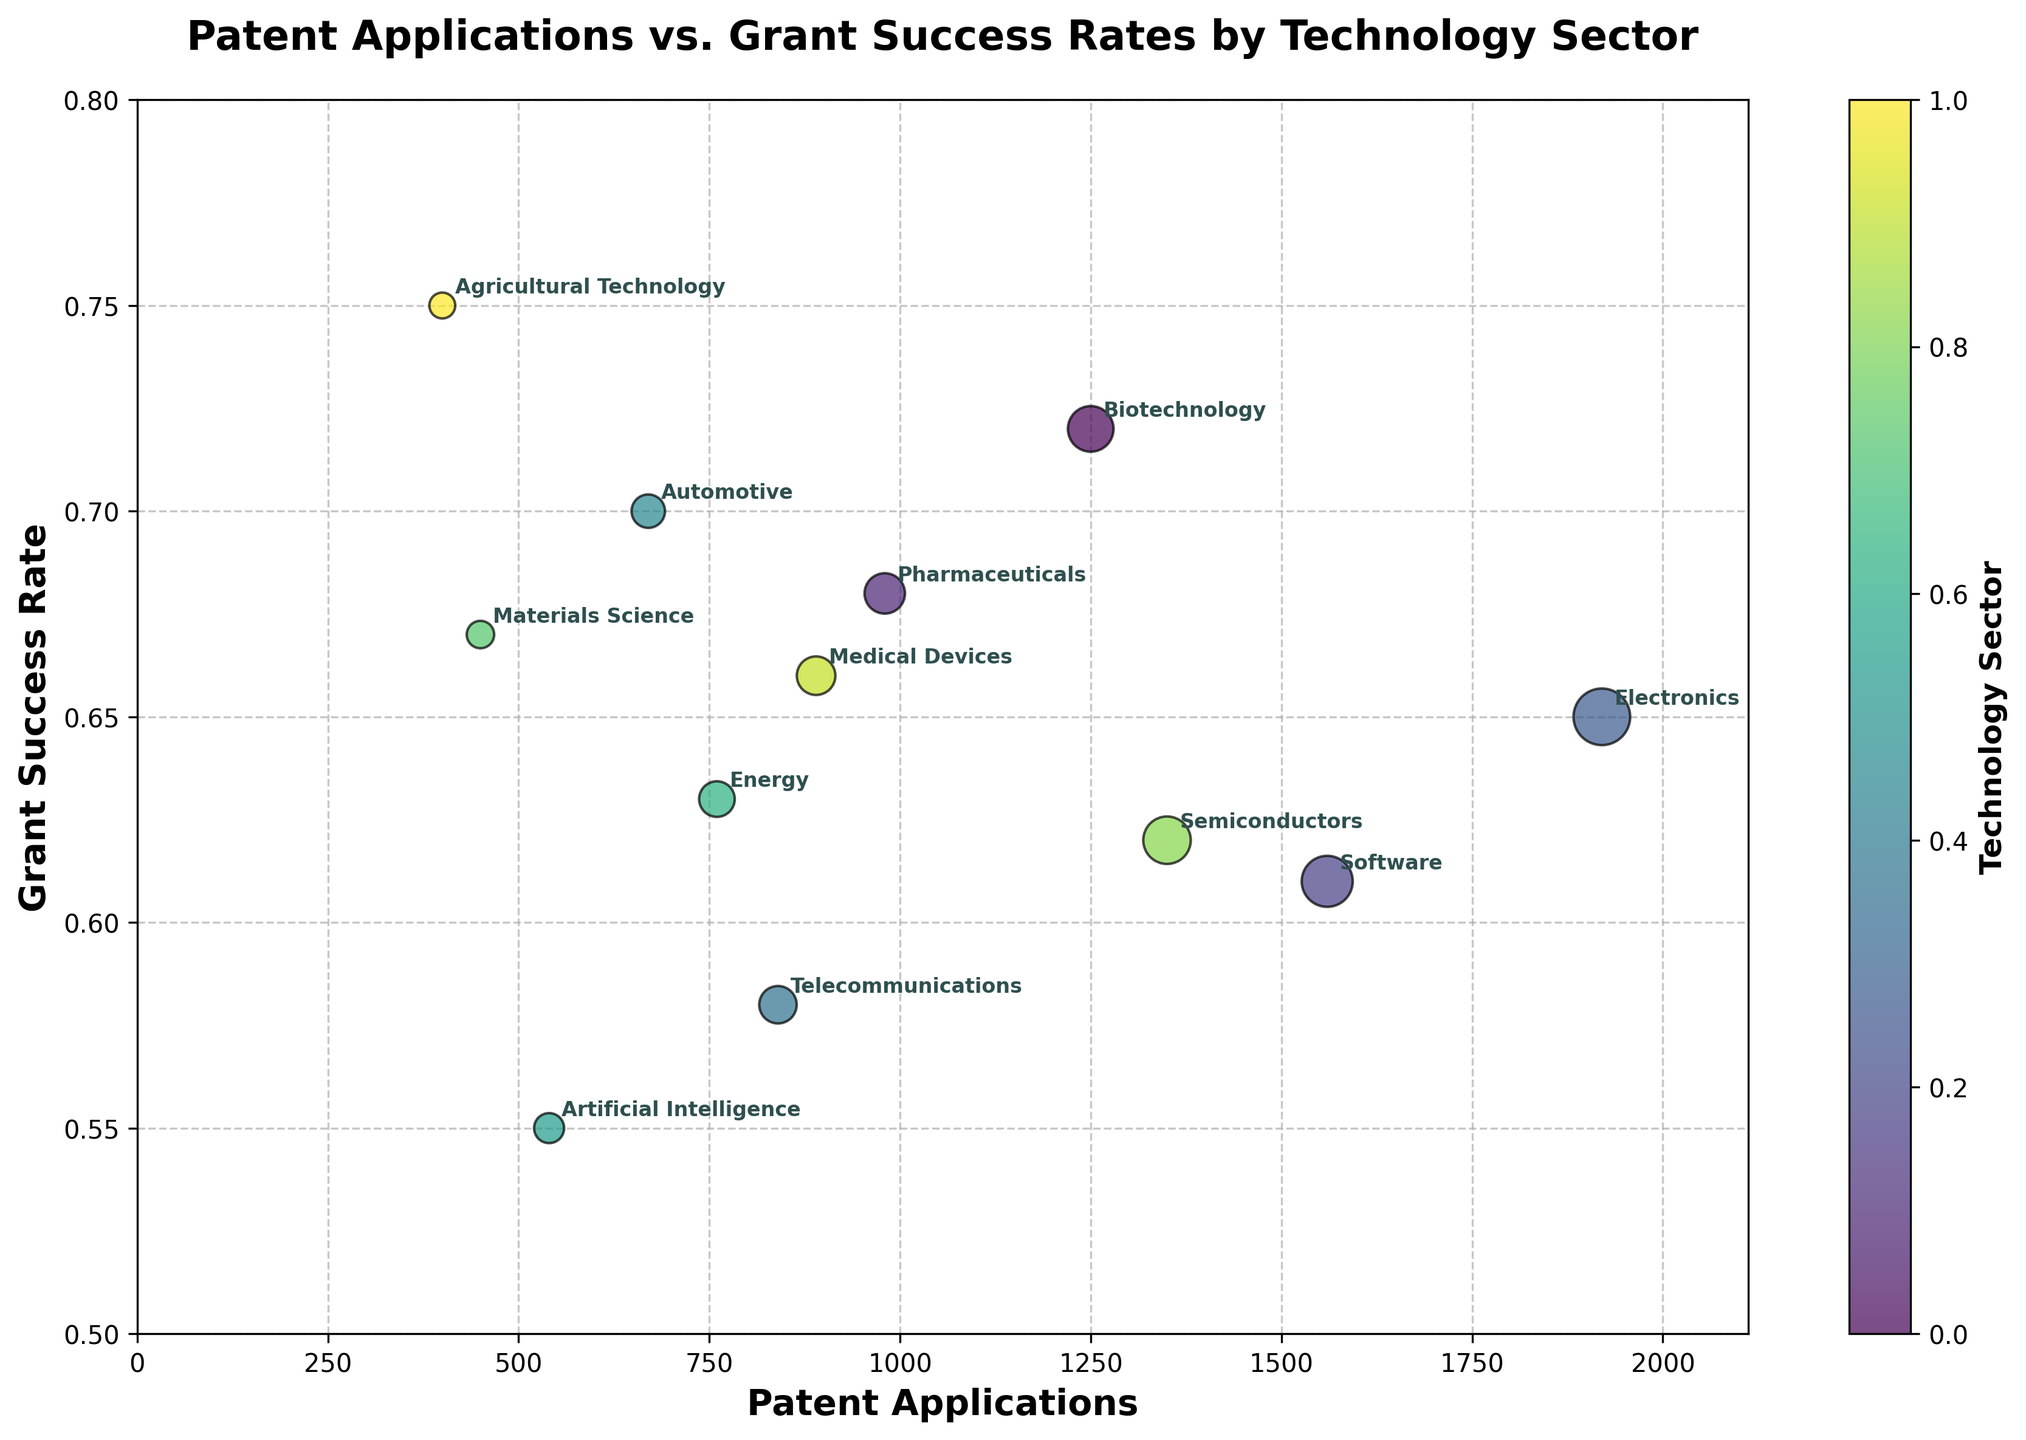What is the title of the figure? The title of the figure is displayed at the top, typically in bold to easily identify the subject of the plot.
Answer: Patent Applications vs. Grant Success Rates by Technology Sector How many technology sectors are plotted in the figure? Count the number of unique data points or annotations corresponding to each sector in the scatter plot. There are 12 distinct sectors shown.
Answer: 12 Which technology sector has the highest number of patent applications? Find the data point (bubble) furthest to the right on the horizontal axis, representing the highest value for patent applications.
Answer: Electronics Which technology sector has the lowest grant success rate? Locate the data point at the lowest position on the vertical axis, which indicates the lowest grant success rate.
Answer: Artificial Intelligence How does the grant success rate of Pharmaceuticals compare with that of Biotechnology? Look at the vertical position of both Pharmaceuticals and Biotechnology. Compare their height on the grant success rate axis. Biotechnology has a higher success rate.
Answer: Biotechnology has a higher success rate than Pharmaceuticals What is the grant success rate for Medical Devices, and how does it compare to Electronics? Identify the vertical position of Medical Devices and Electronics on the grant success rate axis. Compare their respective values. Medical Devices has a grant success rate of 0.66, whereas Electronics is slightly lower at 0.65.
Answer: Medical Devices is higher (0.66) than Electronics (0.65) Which technology sector has more patent applications, Semiconductors or Pharmaceuticals? Compare the horizontal positions of Semiconductors and Pharmaceuticals on the patent applications axis. Semiconductors has more patent applications.
Answer: Semiconductors has more patent applications than Pharmaceuticals What trend can be observed between the number of patent applications and grant success rates across sectors? Examine whether industries with more patent applications generally have higher or lower grant success rates. No clear overall trend is observable; some sectors with many applications have high success rates, while others do not.
Answer: No clear trend between patent applications and grant success rates Which technology sector has the smallest bubble size, and what does it represent? Identify the smallest bubble in the scatter plot, which represents the technology sector with the fewest patent applications. The smallest bubble belongs to Agricultural Technology, indicating it has the fewest applications.
Answer: Agricultural Technology What is the difference in grant success rates between Automotive and Telecommunications sectors? Note the grant success rates for both sectors and calculate the difference between them. Automotive has a success rate of 0.70 while Telecommunications is at 0.58. The difference is 0.70 - 0.58 = 0.12.
Answer: 0.12 